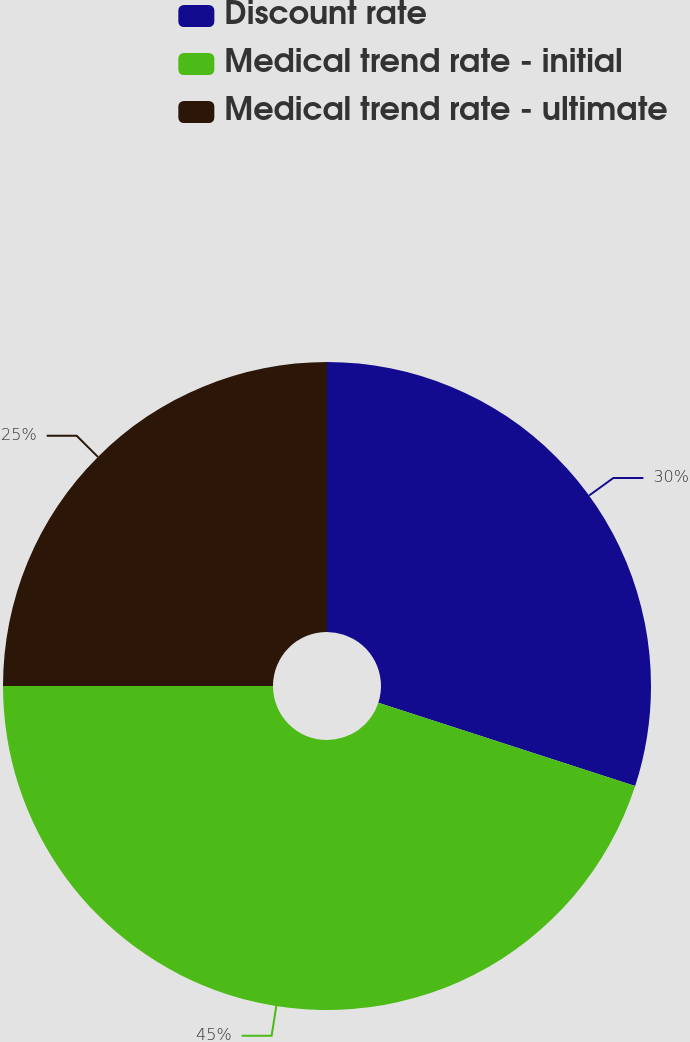<chart> <loc_0><loc_0><loc_500><loc_500><pie_chart><fcel>Discount rate<fcel>Medical trend rate - initial<fcel>Medical trend rate - ultimate<nl><fcel>30.0%<fcel>45.0%<fcel>25.0%<nl></chart> 